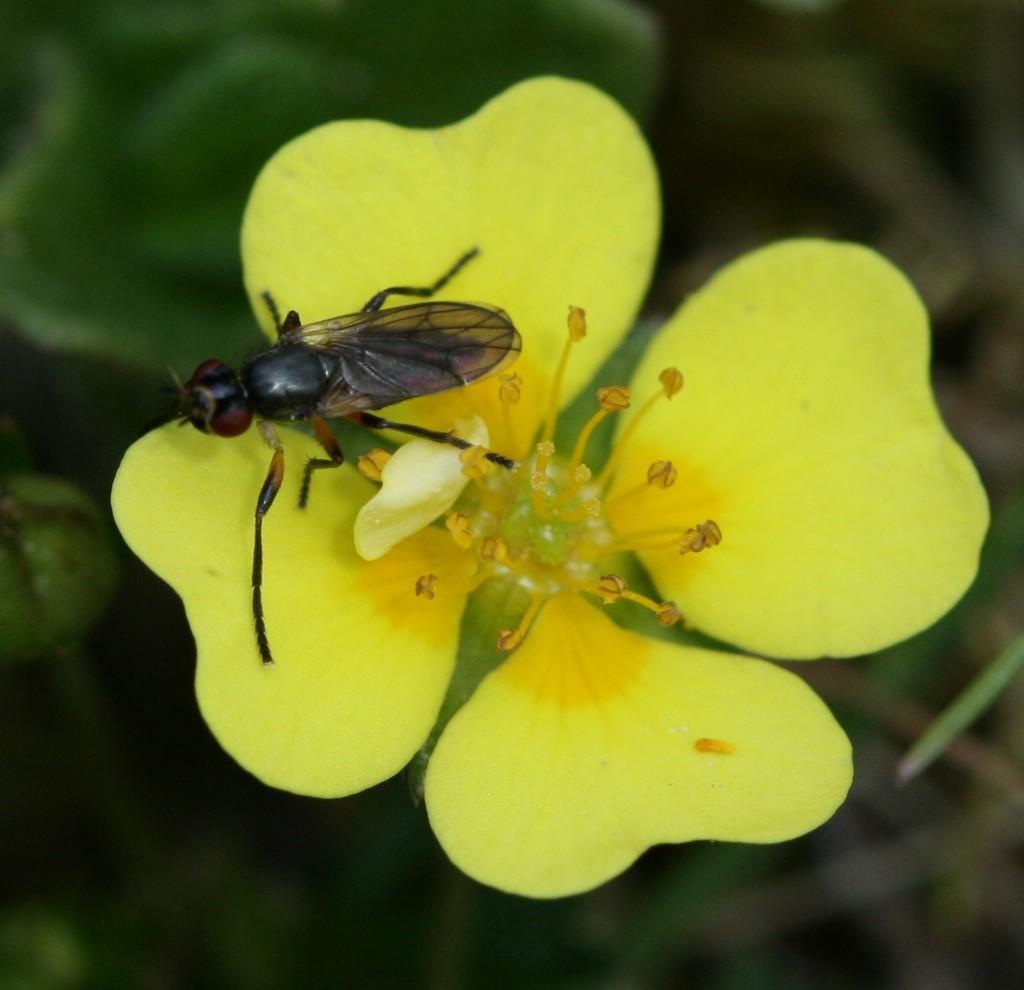Please provide a concise description of this image. There is an insect on a flower in the center of the image. 